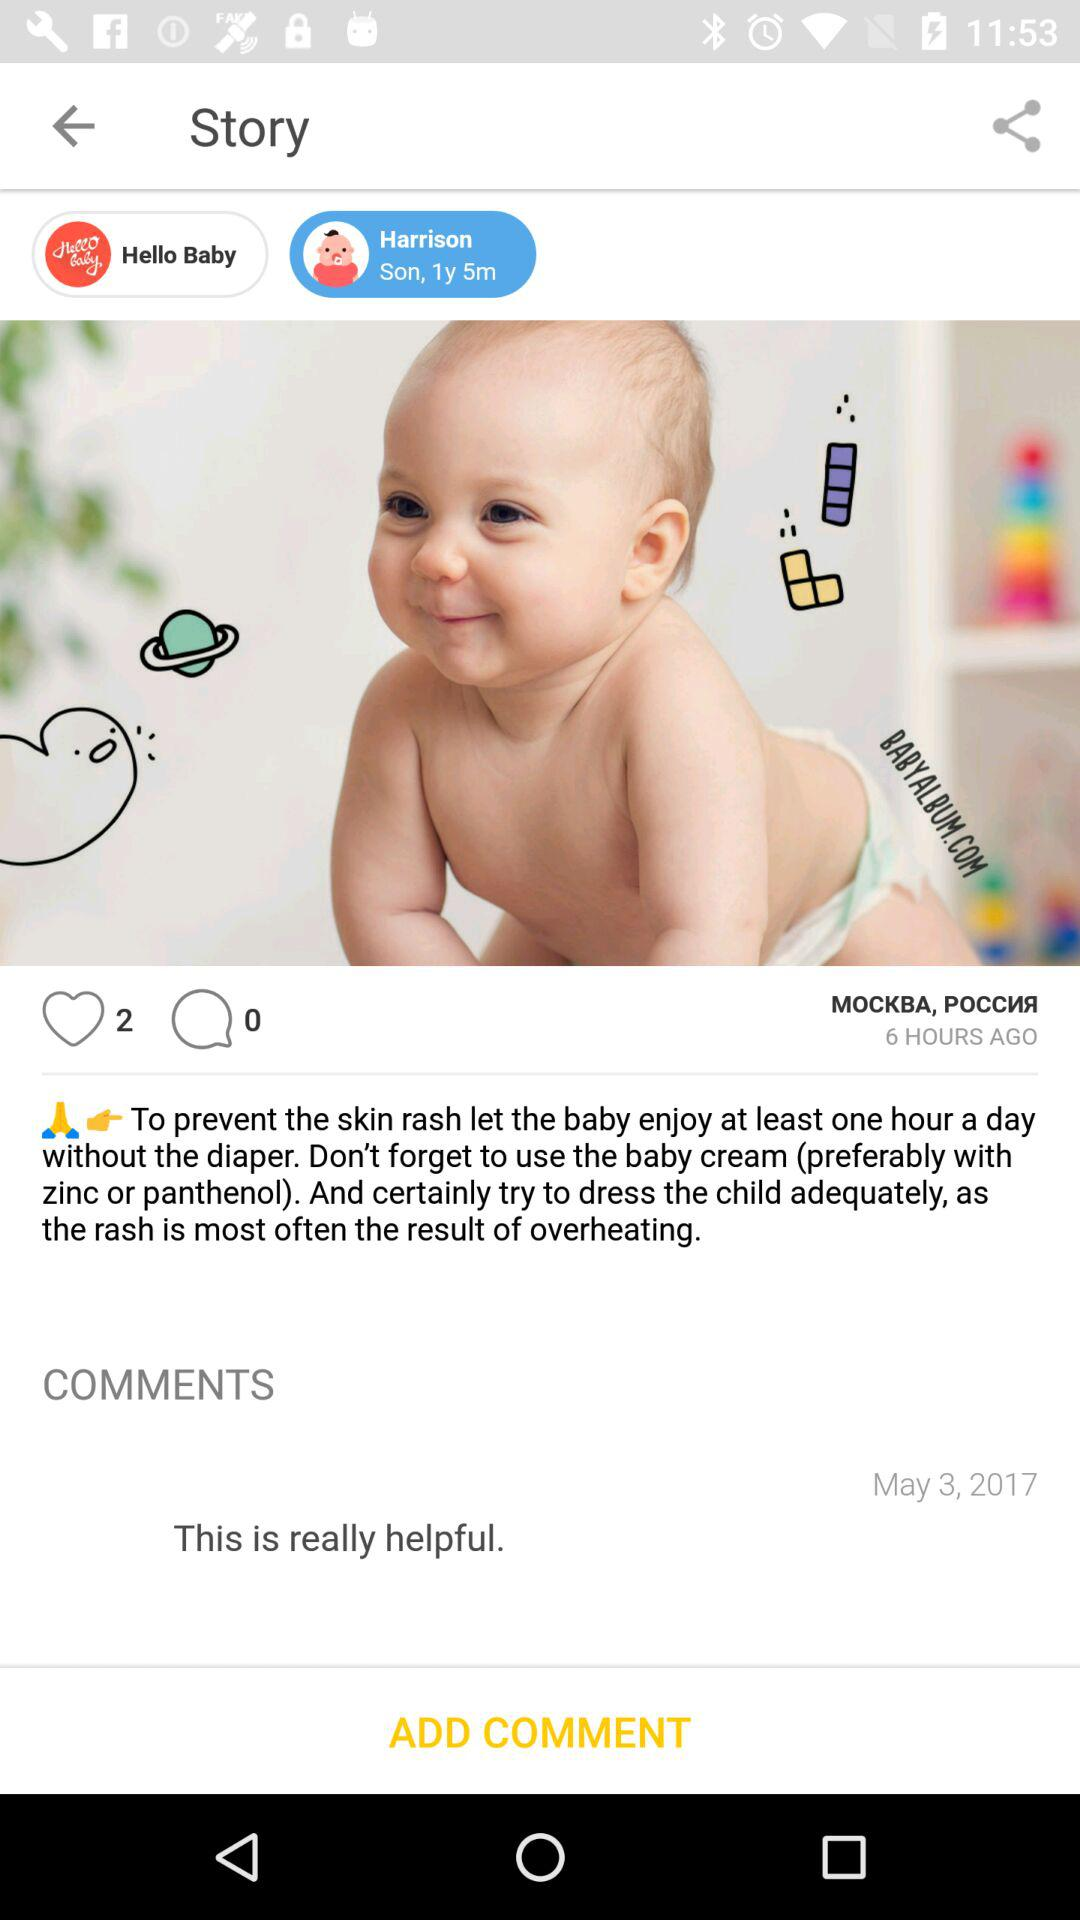When was the post posted? The post was posted 6 hours ago. 